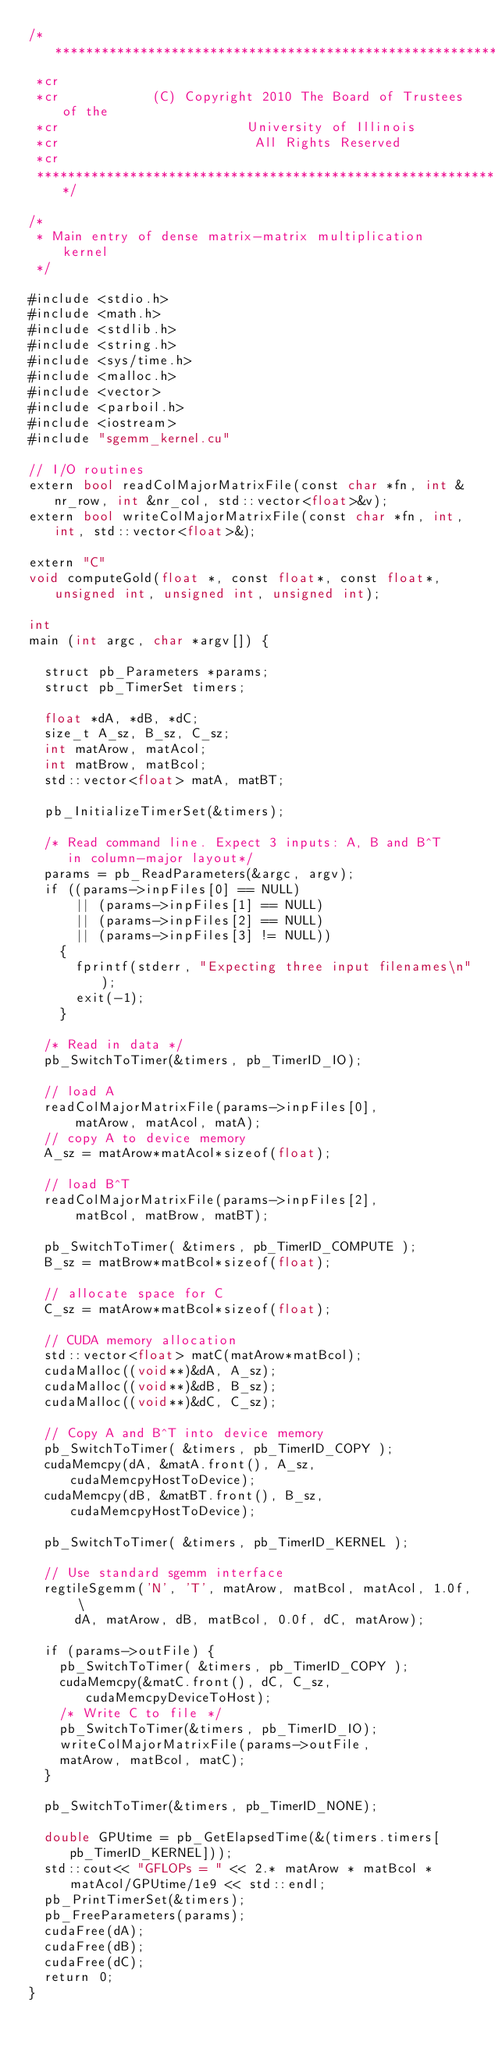<code> <loc_0><loc_0><loc_500><loc_500><_Cuda_>/***************************************************************************
 *cr
 *cr            (C) Copyright 2010 The Board of Trustees of the
 *cr                        University of Illinois
 *cr                         All Rights Reserved
 *cr
 ***************************************************************************/

/* 
 * Main entry of dense matrix-matrix multiplication kernel
 */

#include <stdio.h>
#include <math.h>
#include <stdlib.h>
#include <string.h>
#include <sys/time.h>
#include <malloc.h>
#include <vector>
#include <parboil.h>
#include <iostream>
#include "sgemm_kernel.cu"

// I/O routines
extern bool readColMajorMatrixFile(const char *fn, int &nr_row, int &nr_col, std::vector<float>&v);
extern bool writeColMajorMatrixFile(const char *fn, int, int, std::vector<float>&);

extern "C"
void computeGold(float *, const float*, const float*, unsigned int, unsigned int, unsigned int);

int
main (int argc, char *argv[]) {

  struct pb_Parameters *params;
  struct pb_TimerSet timers;

  float *dA, *dB, *dC;
  size_t A_sz, B_sz, C_sz;
  int matArow, matAcol;
  int matBrow, matBcol;
  std::vector<float> matA, matBT;

  pb_InitializeTimerSet(&timers);

  /* Read command line. Expect 3 inputs: A, B and B^T 
     in column-major layout*/
  params = pb_ReadParameters(&argc, argv);
  if ((params->inpFiles[0] == NULL) 
      || (params->inpFiles[1] == NULL)
      || (params->inpFiles[2] == NULL)
      || (params->inpFiles[3] != NULL))
    {
      fprintf(stderr, "Expecting three input filenames\n");
      exit(-1);
    }
 
  /* Read in data */
  pb_SwitchToTimer(&timers, pb_TimerID_IO);

  // load A
  readColMajorMatrixFile(params->inpFiles[0],
      matArow, matAcol, matA);
  // copy A to device memory
  A_sz = matArow*matAcol*sizeof(float);

  // load B^T
  readColMajorMatrixFile(params->inpFiles[2],
      matBcol, matBrow, matBT);

  pb_SwitchToTimer( &timers, pb_TimerID_COMPUTE );
  B_sz = matBrow*matBcol*sizeof(float);

  // allocate space for C
  C_sz = matArow*matBcol*sizeof(float);

  // CUDA memory allocation
  std::vector<float> matC(matArow*matBcol);
  cudaMalloc((void**)&dA, A_sz);
  cudaMalloc((void**)&dB, B_sz);
  cudaMalloc((void**)&dC, C_sz);

  // Copy A and B^T into device memory
  pb_SwitchToTimer( &timers, pb_TimerID_COPY );
  cudaMemcpy(dA, &matA.front(), A_sz, cudaMemcpyHostToDevice); 
  cudaMemcpy(dB, &matBT.front(), B_sz, cudaMemcpyHostToDevice); 

  pb_SwitchToTimer( &timers, pb_TimerID_KERNEL );

  // Use standard sgemm interface
  regtileSgemm('N', 'T', matArow, matBcol, matAcol, 1.0f, \
      dA, matArow, dB, matBcol, 0.0f, dC, matArow);

  if (params->outFile) {
    pb_SwitchToTimer( &timers, pb_TimerID_COPY );
    cudaMemcpy(&matC.front(), dC, C_sz, cudaMemcpyDeviceToHost);
    /* Write C to file */
    pb_SwitchToTimer(&timers, pb_TimerID_IO);
    writeColMajorMatrixFile(params->outFile,
	matArow, matBcol, matC); 
  }

  pb_SwitchToTimer(&timers, pb_TimerID_NONE);

  double GPUtime = pb_GetElapsedTime(&(timers.timers[pb_TimerID_KERNEL]));
  std::cout<< "GFLOPs = " << 2.* matArow * matBcol * matAcol/GPUtime/1e9 << std::endl;
  pb_PrintTimerSet(&timers);
  pb_FreeParameters(params);
  cudaFree(dA);
  cudaFree(dB);
  cudaFree(dC);
  return 0;
}
</code> 